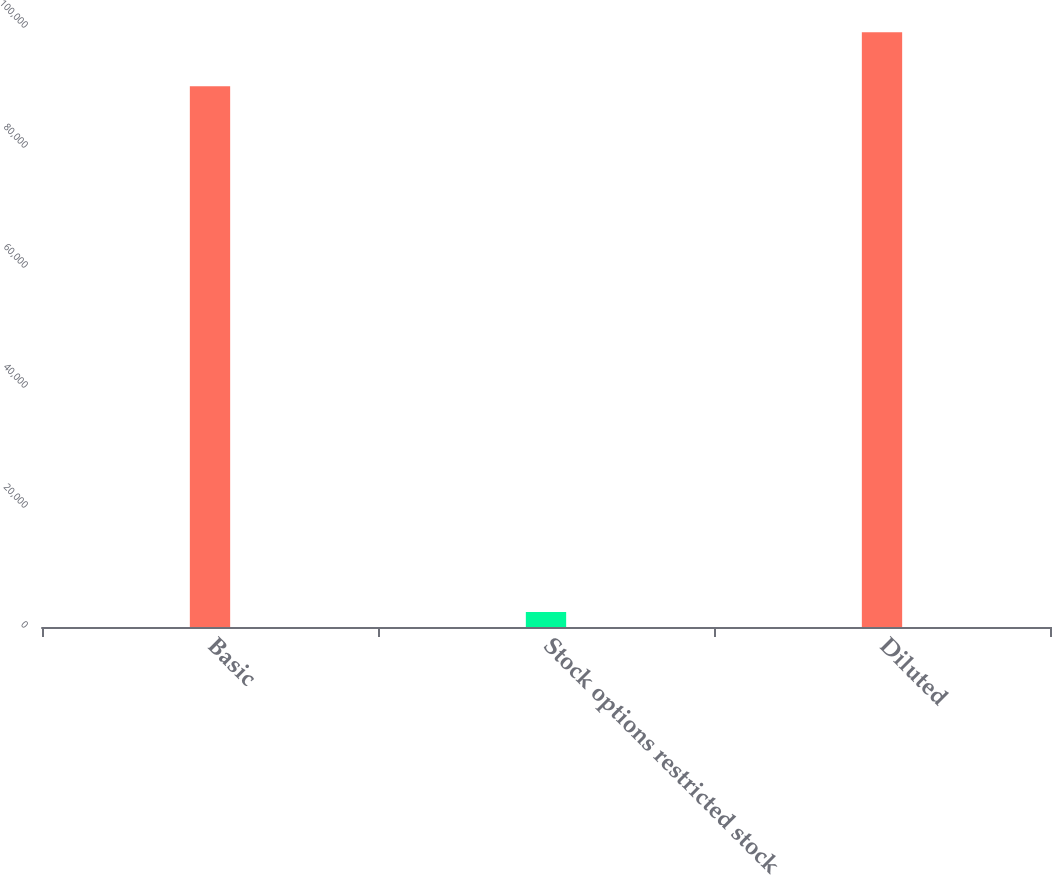<chart> <loc_0><loc_0><loc_500><loc_500><bar_chart><fcel>Basic<fcel>Stock options restricted stock<fcel>Diluted<nl><fcel>90120<fcel>2500<fcel>99132<nl></chart> 